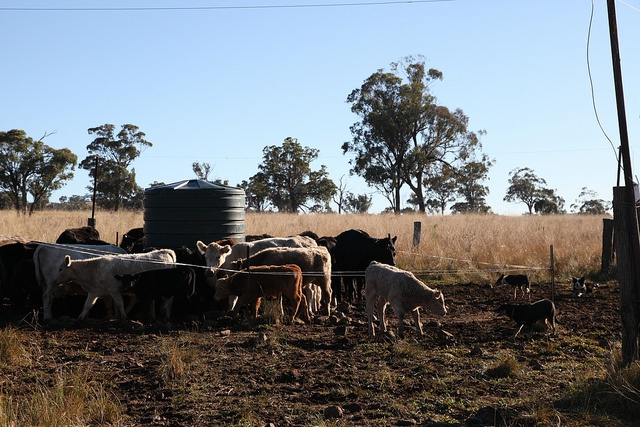Describe the objects in this image and their specific colors. I can see cow in lightblue, black, gray, ivory, and darkgray tones, cow in lightblue, black, maroon, gray, and tan tones, cow in lightblue, black, and gray tones, cow in lightblue, black, and gray tones, and cow in lightblue, black, and gray tones in this image. 